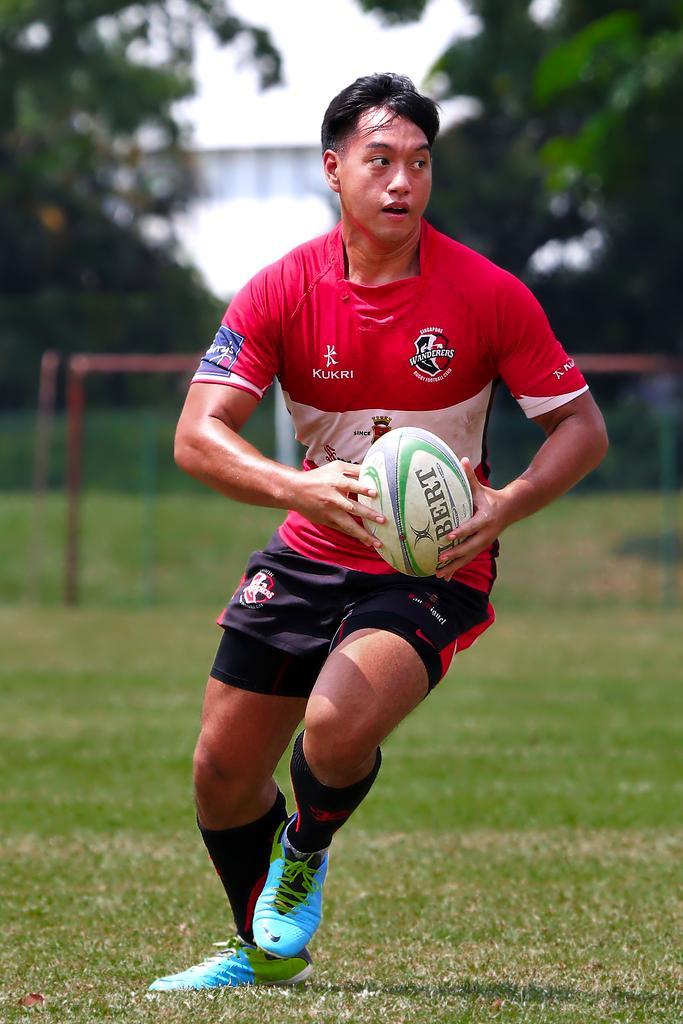How would you summarize this image in a sentence or two? In the center of the image there is a person holding ball and standing. In the background we can see net, trees and sky. 